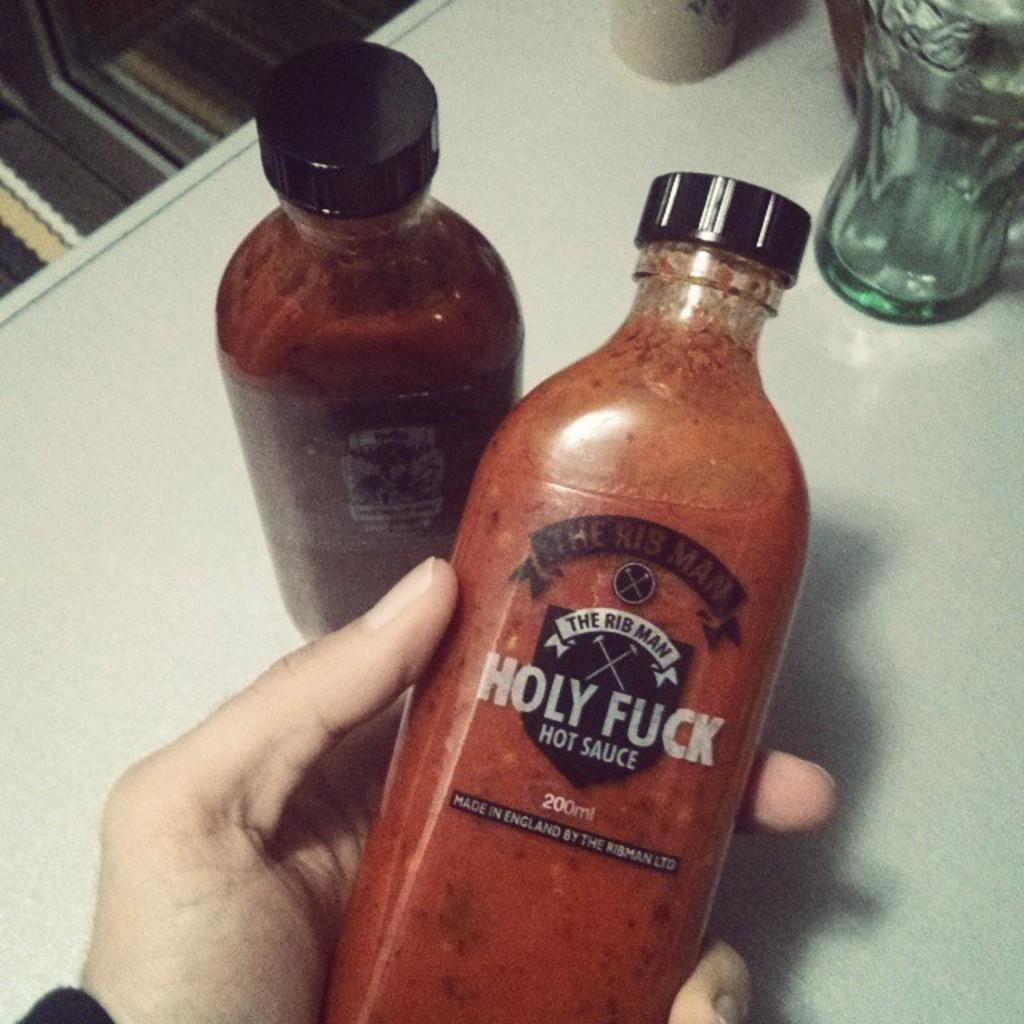<image>
Share a concise interpretation of the image provided. A bottle of hot sauce says it contains 200 ml of sauce. 